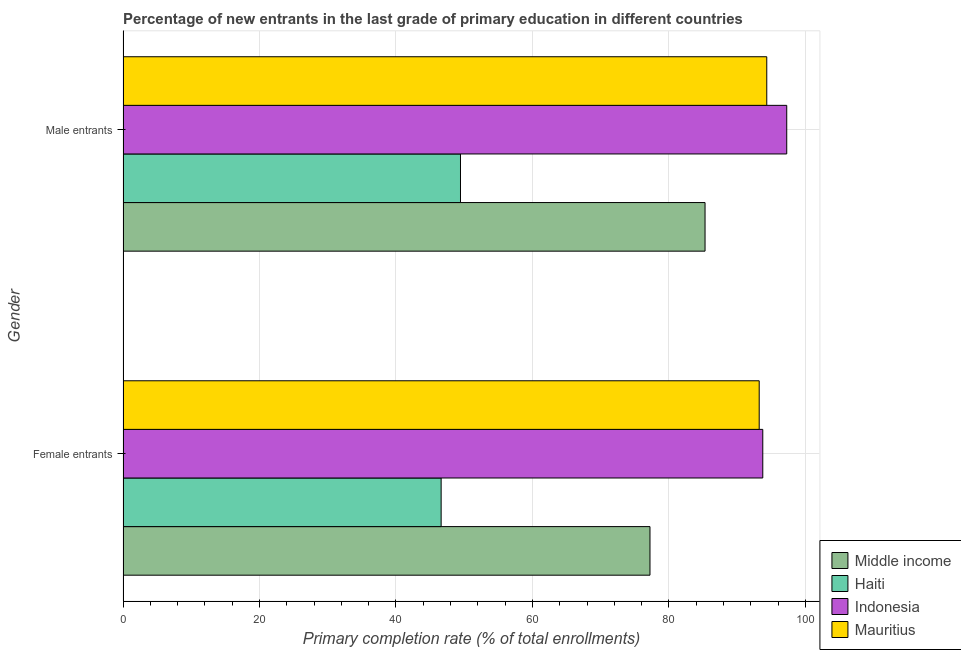How many groups of bars are there?
Give a very brief answer. 2. Are the number of bars per tick equal to the number of legend labels?
Your answer should be compact. Yes. How many bars are there on the 1st tick from the top?
Your response must be concise. 4. What is the label of the 2nd group of bars from the top?
Keep it short and to the point. Female entrants. What is the primary completion rate of male entrants in Middle income?
Your response must be concise. 85.29. Across all countries, what is the maximum primary completion rate of male entrants?
Give a very brief answer. 97.26. Across all countries, what is the minimum primary completion rate of male entrants?
Your answer should be very brief. 49.46. In which country was the primary completion rate of female entrants minimum?
Ensure brevity in your answer.  Haiti. What is the total primary completion rate of male entrants in the graph?
Provide a short and direct response. 326.35. What is the difference between the primary completion rate of male entrants in Indonesia and that in Mauritius?
Keep it short and to the point. 2.93. What is the difference between the primary completion rate of male entrants in Haiti and the primary completion rate of female entrants in Mauritius?
Offer a terse response. -43.77. What is the average primary completion rate of female entrants per country?
Offer a terse response. 77.71. What is the difference between the primary completion rate of male entrants and primary completion rate of female entrants in Haiti?
Your answer should be compact. 2.84. In how many countries, is the primary completion rate of female entrants greater than 92 %?
Provide a short and direct response. 2. What is the ratio of the primary completion rate of female entrants in Indonesia to that in Haiti?
Keep it short and to the point. 2.01. Is the primary completion rate of male entrants in Mauritius less than that in Middle income?
Keep it short and to the point. No. What does the 2nd bar from the top in Female entrants represents?
Your response must be concise. Indonesia. What does the 1st bar from the bottom in Female entrants represents?
Provide a succinct answer. Middle income. How many bars are there?
Give a very brief answer. 8. How many countries are there in the graph?
Make the answer very short. 4. Are the values on the major ticks of X-axis written in scientific E-notation?
Your answer should be compact. No. Does the graph contain any zero values?
Keep it short and to the point. No. Does the graph contain grids?
Make the answer very short. Yes. How many legend labels are there?
Your answer should be compact. 4. How are the legend labels stacked?
Make the answer very short. Vertical. What is the title of the graph?
Offer a very short reply. Percentage of new entrants in the last grade of primary education in different countries. What is the label or title of the X-axis?
Make the answer very short. Primary completion rate (% of total enrollments). What is the label or title of the Y-axis?
Keep it short and to the point. Gender. What is the Primary completion rate (% of total enrollments) of Middle income in Female entrants?
Ensure brevity in your answer.  77.23. What is the Primary completion rate (% of total enrollments) of Haiti in Female entrants?
Ensure brevity in your answer.  46.62. What is the Primary completion rate (% of total enrollments) in Indonesia in Female entrants?
Provide a short and direct response. 93.75. What is the Primary completion rate (% of total enrollments) in Mauritius in Female entrants?
Offer a terse response. 93.23. What is the Primary completion rate (% of total enrollments) of Middle income in Male entrants?
Give a very brief answer. 85.29. What is the Primary completion rate (% of total enrollments) in Haiti in Male entrants?
Provide a short and direct response. 49.46. What is the Primary completion rate (% of total enrollments) in Indonesia in Male entrants?
Offer a terse response. 97.26. What is the Primary completion rate (% of total enrollments) of Mauritius in Male entrants?
Give a very brief answer. 94.34. Across all Gender, what is the maximum Primary completion rate (% of total enrollments) of Middle income?
Provide a succinct answer. 85.29. Across all Gender, what is the maximum Primary completion rate (% of total enrollments) in Haiti?
Offer a very short reply. 49.46. Across all Gender, what is the maximum Primary completion rate (% of total enrollments) of Indonesia?
Your answer should be very brief. 97.26. Across all Gender, what is the maximum Primary completion rate (% of total enrollments) of Mauritius?
Make the answer very short. 94.34. Across all Gender, what is the minimum Primary completion rate (% of total enrollments) in Middle income?
Ensure brevity in your answer.  77.23. Across all Gender, what is the minimum Primary completion rate (% of total enrollments) in Haiti?
Offer a terse response. 46.62. Across all Gender, what is the minimum Primary completion rate (% of total enrollments) of Indonesia?
Offer a very short reply. 93.75. Across all Gender, what is the minimum Primary completion rate (% of total enrollments) in Mauritius?
Your answer should be compact. 93.23. What is the total Primary completion rate (% of total enrollments) in Middle income in the graph?
Your answer should be compact. 162.52. What is the total Primary completion rate (% of total enrollments) of Haiti in the graph?
Ensure brevity in your answer.  96.08. What is the total Primary completion rate (% of total enrollments) in Indonesia in the graph?
Keep it short and to the point. 191.02. What is the total Primary completion rate (% of total enrollments) in Mauritius in the graph?
Provide a succinct answer. 187.57. What is the difference between the Primary completion rate (% of total enrollments) in Middle income in Female entrants and that in Male entrants?
Offer a very short reply. -8.07. What is the difference between the Primary completion rate (% of total enrollments) in Haiti in Female entrants and that in Male entrants?
Offer a very short reply. -2.84. What is the difference between the Primary completion rate (% of total enrollments) of Indonesia in Female entrants and that in Male entrants?
Offer a terse response. -3.51. What is the difference between the Primary completion rate (% of total enrollments) of Mauritius in Female entrants and that in Male entrants?
Give a very brief answer. -1.11. What is the difference between the Primary completion rate (% of total enrollments) of Middle income in Female entrants and the Primary completion rate (% of total enrollments) of Haiti in Male entrants?
Provide a succinct answer. 27.77. What is the difference between the Primary completion rate (% of total enrollments) in Middle income in Female entrants and the Primary completion rate (% of total enrollments) in Indonesia in Male entrants?
Offer a very short reply. -20.04. What is the difference between the Primary completion rate (% of total enrollments) in Middle income in Female entrants and the Primary completion rate (% of total enrollments) in Mauritius in Male entrants?
Give a very brief answer. -17.11. What is the difference between the Primary completion rate (% of total enrollments) of Haiti in Female entrants and the Primary completion rate (% of total enrollments) of Indonesia in Male entrants?
Offer a terse response. -50.64. What is the difference between the Primary completion rate (% of total enrollments) in Haiti in Female entrants and the Primary completion rate (% of total enrollments) in Mauritius in Male entrants?
Provide a succinct answer. -47.72. What is the difference between the Primary completion rate (% of total enrollments) in Indonesia in Female entrants and the Primary completion rate (% of total enrollments) in Mauritius in Male entrants?
Make the answer very short. -0.58. What is the average Primary completion rate (% of total enrollments) in Middle income per Gender?
Ensure brevity in your answer.  81.26. What is the average Primary completion rate (% of total enrollments) of Haiti per Gender?
Give a very brief answer. 48.04. What is the average Primary completion rate (% of total enrollments) of Indonesia per Gender?
Make the answer very short. 95.51. What is the average Primary completion rate (% of total enrollments) in Mauritius per Gender?
Provide a short and direct response. 93.78. What is the difference between the Primary completion rate (% of total enrollments) in Middle income and Primary completion rate (% of total enrollments) in Haiti in Female entrants?
Provide a succinct answer. 30.61. What is the difference between the Primary completion rate (% of total enrollments) in Middle income and Primary completion rate (% of total enrollments) in Indonesia in Female entrants?
Ensure brevity in your answer.  -16.53. What is the difference between the Primary completion rate (% of total enrollments) of Middle income and Primary completion rate (% of total enrollments) of Mauritius in Female entrants?
Your answer should be very brief. -16. What is the difference between the Primary completion rate (% of total enrollments) of Haiti and Primary completion rate (% of total enrollments) of Indonesia in Female entrants?
Offer a terse response. -47.13. What is the difference between the Primary completion rate (% of total enrollments) in Haiti and Primary completion rate (% of total enrollments) in Mauritius in Female entrants?
Offer a terse response. -46.61. What is the difference between the Primary completion rate (% of total enrollments) of Indonesia and Primary completion rate (% of total enrollments) of Mauritius in Female entrants?
Offer a very short reply. 0.52. What is the difference between the Primary completion rate (% of total enrollments) in Middle income and Primary completion rate (% of total enrollments) in Haiti in Male entrants?
Your response must be concise. 35.84. What is the difference between the Primary completion rate (% of total enrollments) of Middle income and Primary completion rate (% of total enrollments) of Indonesia in Male entrants?
Your answer should be very brief. -11.97. What is the difference between the Primary completion rate (% of total enrollments) in Middle income and Primary completion rate (% of total enrollments) in Mauritius in Male entrants?
Provide a succinct answer. -9.04. What is the difference between the Primary completion rate (% of total enrollments) in Haiti and Primary completion rate (% of total enrollments) in Indonesia in Male entrants?
Make the answer very short. -47.81. What is the difference between the Primary completion rate (% of total enrollments) of Haiti and Primary completion rate (% of total enrollments) of Mauritius in Male entrants?
Your answer should be very brief. -44.88. What is the difference between the Primary completion rate (% of total enrollments) in Indonesia and Primary completion rate (% of total enrollments) in Mauritius in Male entrants?
Offer a very short reply. 2.93. What is the ratio of the Primary completion rate (% of total enrollments) of Middle income in Female entrants to that in Male entrants?
Offer a terse response. 0.91. What is the ratio of the Primary completion rate (% of total enrollments) in Haiti in Female entrants to that in Male entrants?
Keep it short and to the point. 0.94. What is the ratio of the Primary completion rate (% of total enrollments) in Indonesia in Female entrants to that in Male entrants?
Offer a terse response. 0.96. What is the ratio of the Primary completion rate (% of total enrollments) of Mauritius in Female entrants to that in Male entrants?
Your answer should be very brief. 0.99. What is the difference between the highest and the second highest Primary completion rate (% of total enrollments) in Middle income?
Provide a short and direct response. 8.07. What is the difference between the highest and the second highest Primary completion rate (% of total enrollments) in Haiti?
Give a very brief answer. 2.84. What is the difference between the highest and the second highest Primary completion rate (% of total enrollments) of Indonesia?
Keep it short and to the point. 3.51. What is the difference between the highest and the second highest Primary completion rate (% of total enrollments) in Mauritius?
Make the answer very short. 1.11. What is the difference between the highest and the lowest Primary completion rate (% of total enrollments) of Middle income?
Your answer should be very brief. 8.07. What is the difference between the highest and the lowest Primary completion rate (% of total enrollments) in Haiti?
Your answer should be compact. 2.84. What is the difference between the highest and the lowest Primary completion rate (% of total enrollments) in Indonesia?
Provide a succinct answer. 3.51. What is the difference between the highest and the lowest Primary completion rate (% of total enrollments) of Mauritius?
Your answer should be very brief. 1.11. 